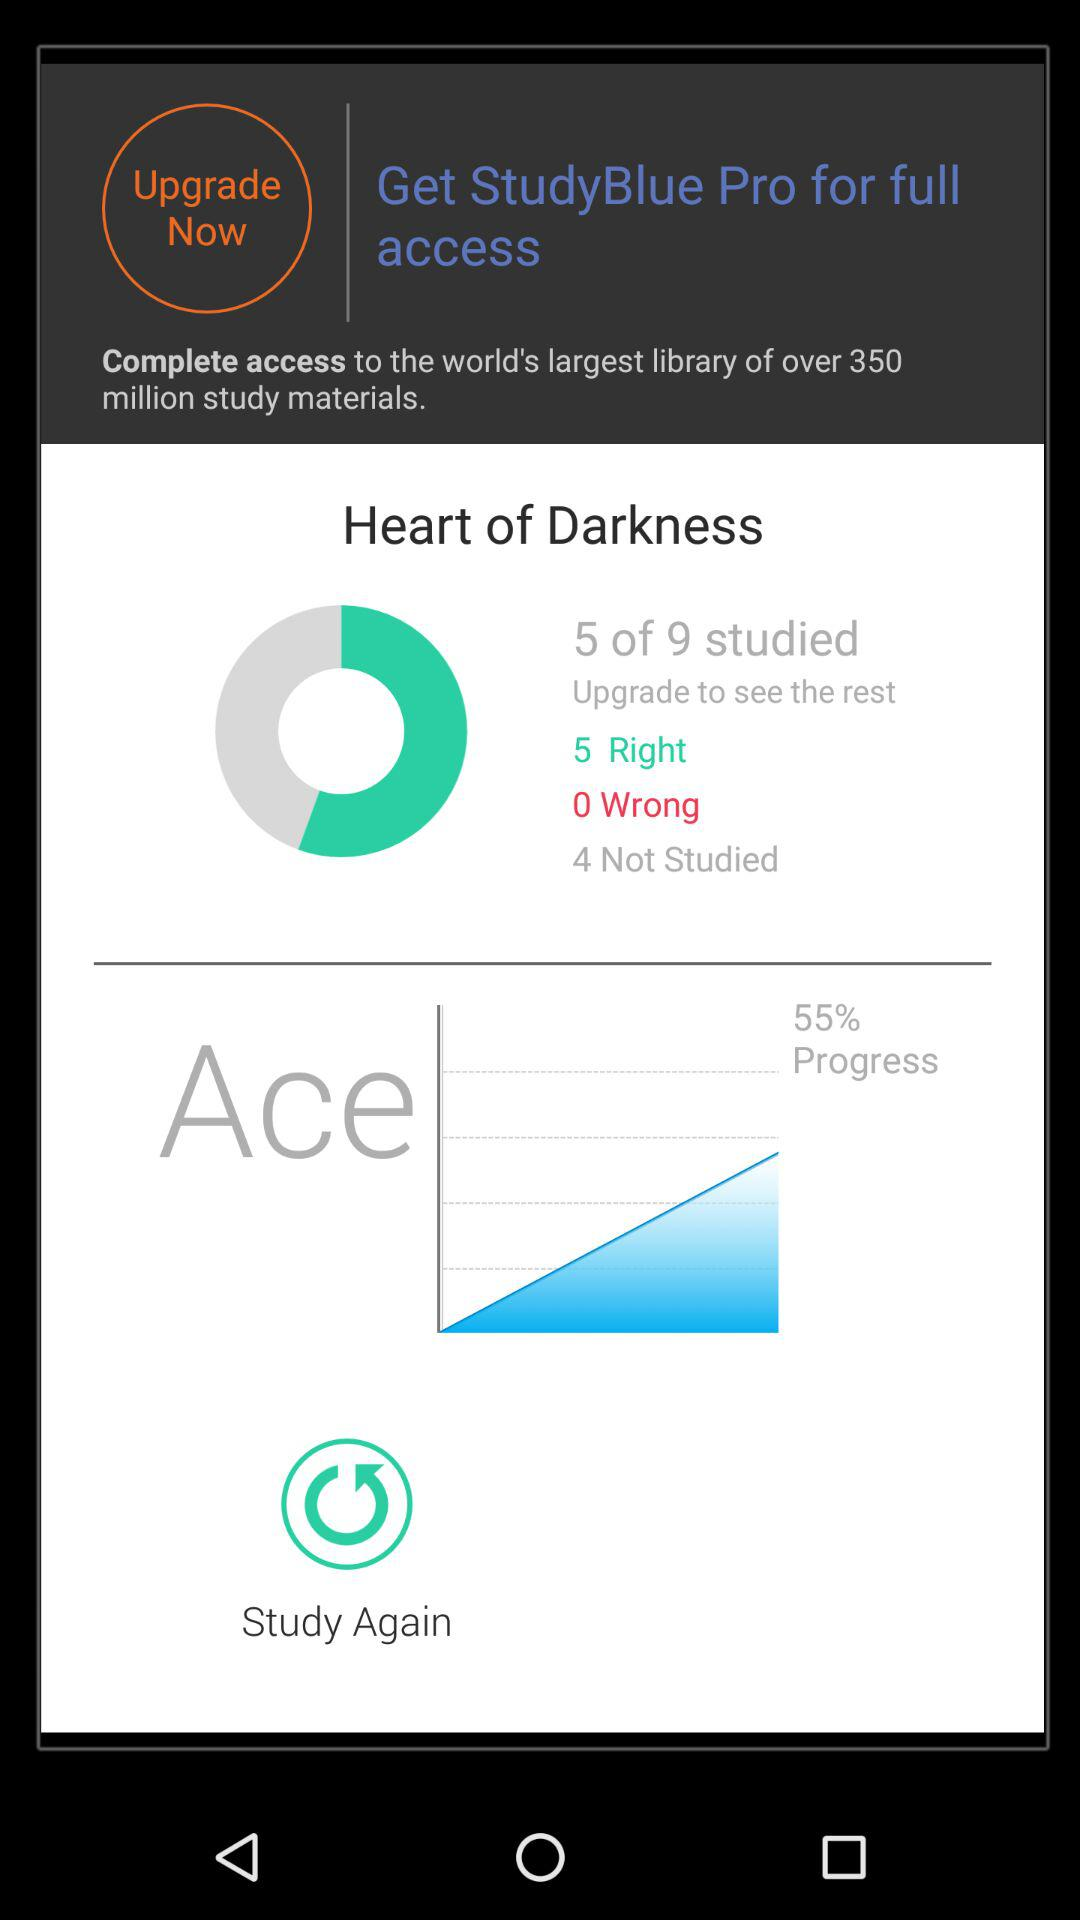What is the progress percentage of the "Ace"? The progress percentage is 55. 